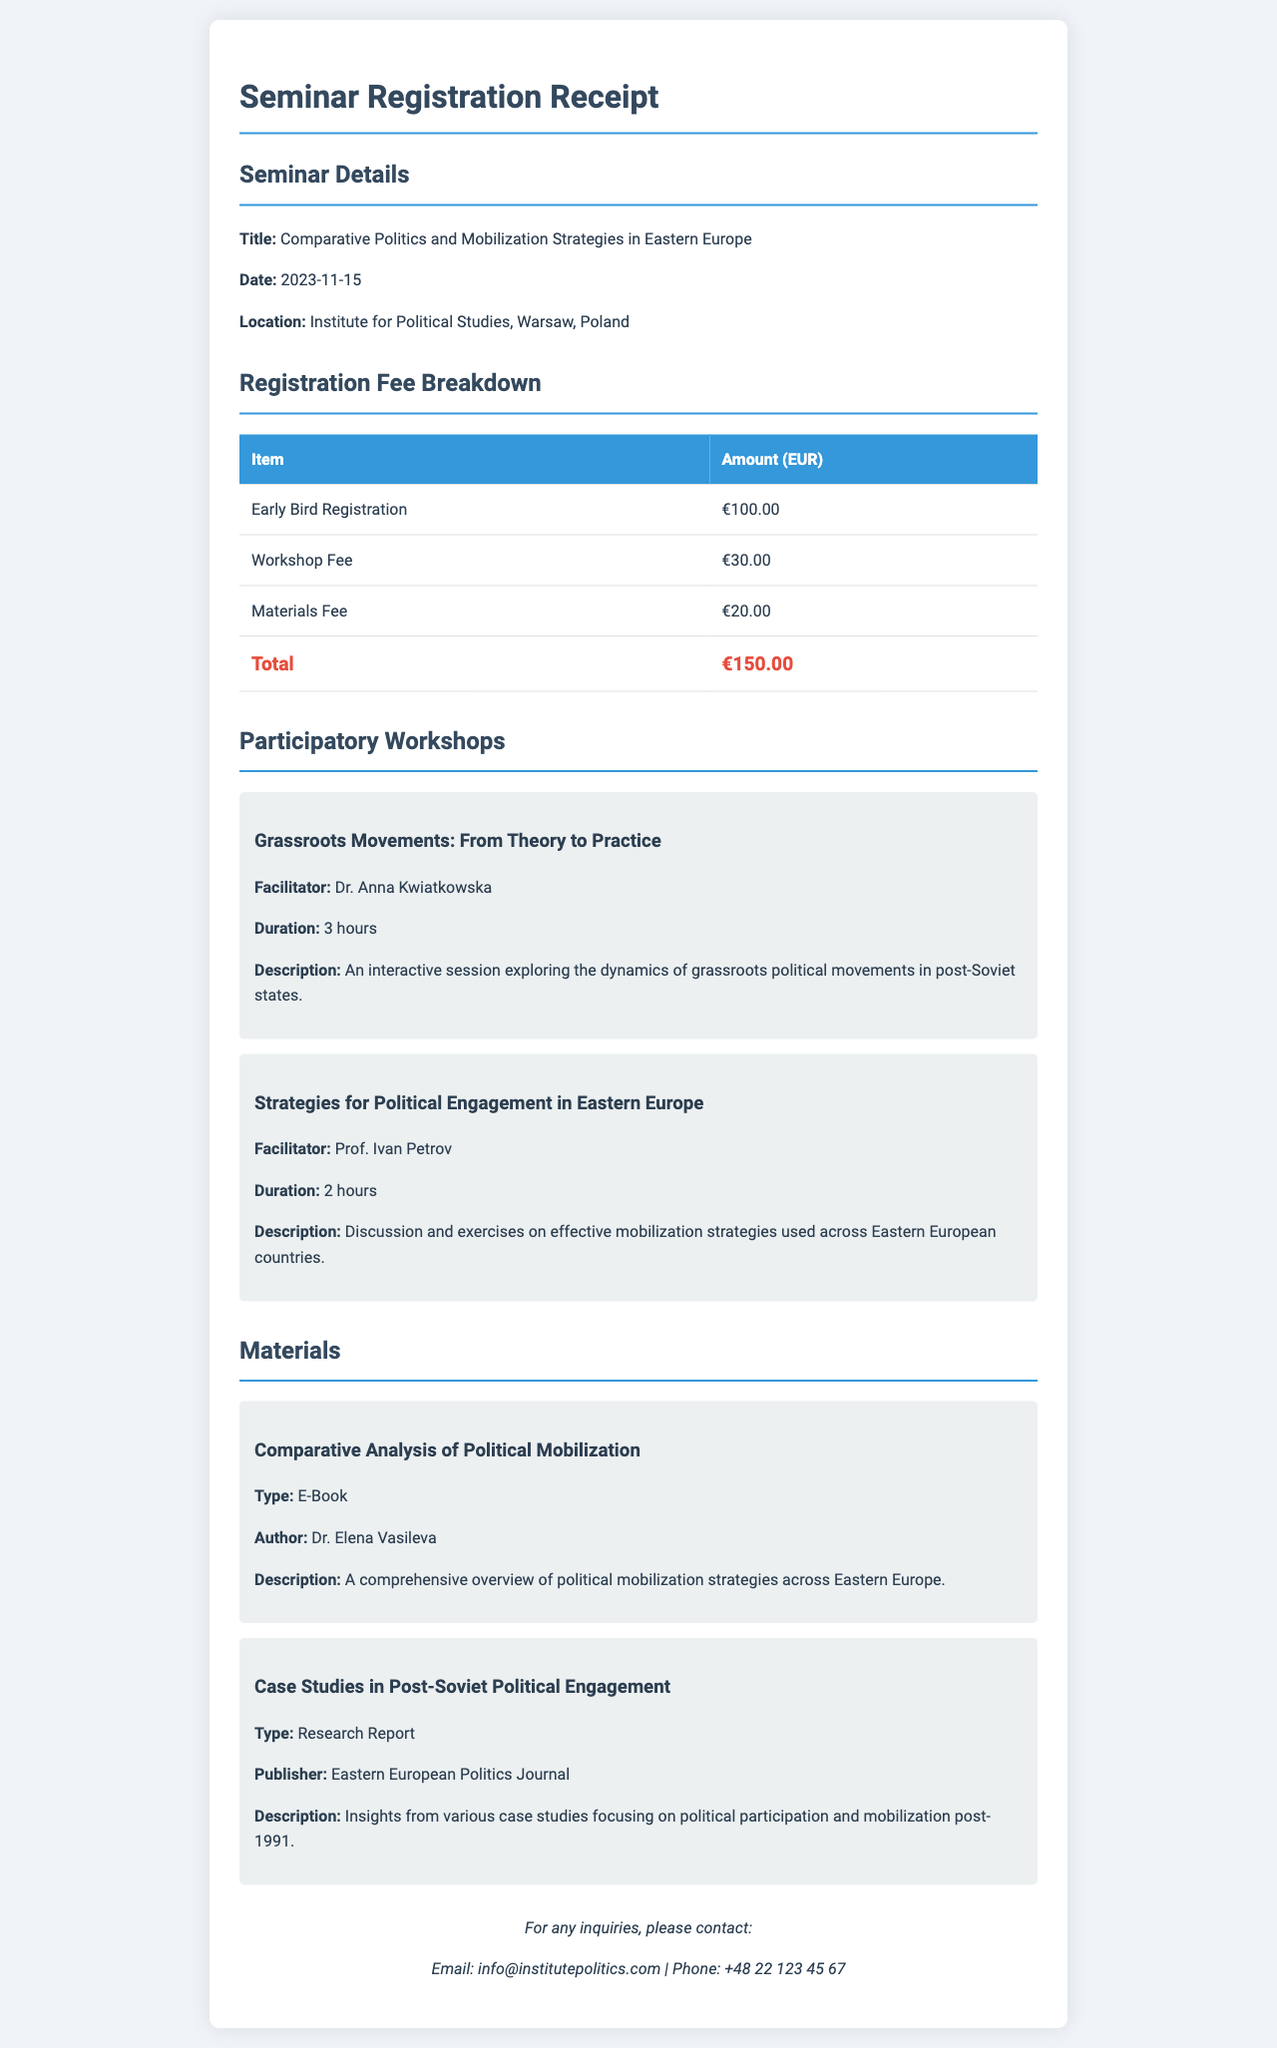What is the title of the seminar? The title of the seminar is clearly mentioned in the document under seminar details.
Answer: Comparative Politics and Mobilization Strategies in Eastern Europe What is the total registration fee? The total registration fee is found in the registration fee breakdown section of the document.
Answer: €150.00 Who is the facilitator for the workshop on grassroots movements? The facilitator's name is provided in the participatory workshops section for the specific workshop.
Answer: Dr. Anna Kwiatkowska When is the seminar scheduled to take place? The date of the seminar is specified under the seminar details section of the document.
Answer: 2023-11-15 What type of material is the "Comparative Analysis of Political Mobilization"? The type of material is mentioned in the materials section related to specific resources provided in the seminar.
Answer: E-Book How long is the workshop on political engagement? The duration of the workshop is provided in the description of the relevant participatory workshop.
Answer: 2 hours What is the location of the seminar? The location of the seminar is detailed in the seminar details.
Answer: Institute for Political Studies, Warsaw, Poland How much is the workshop fee? The fee for the workshop is listed in the registration fee breakdown.
Answer: €30.00 